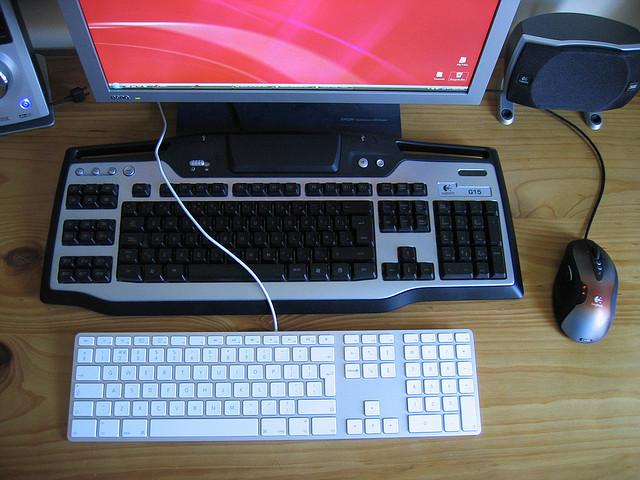Is the mouse wired or wireless?
Answer briefly. Wired. What color is the keyboard?
Write a very short answer. White. How many keyboards are there?
Keep it brief. 2. 